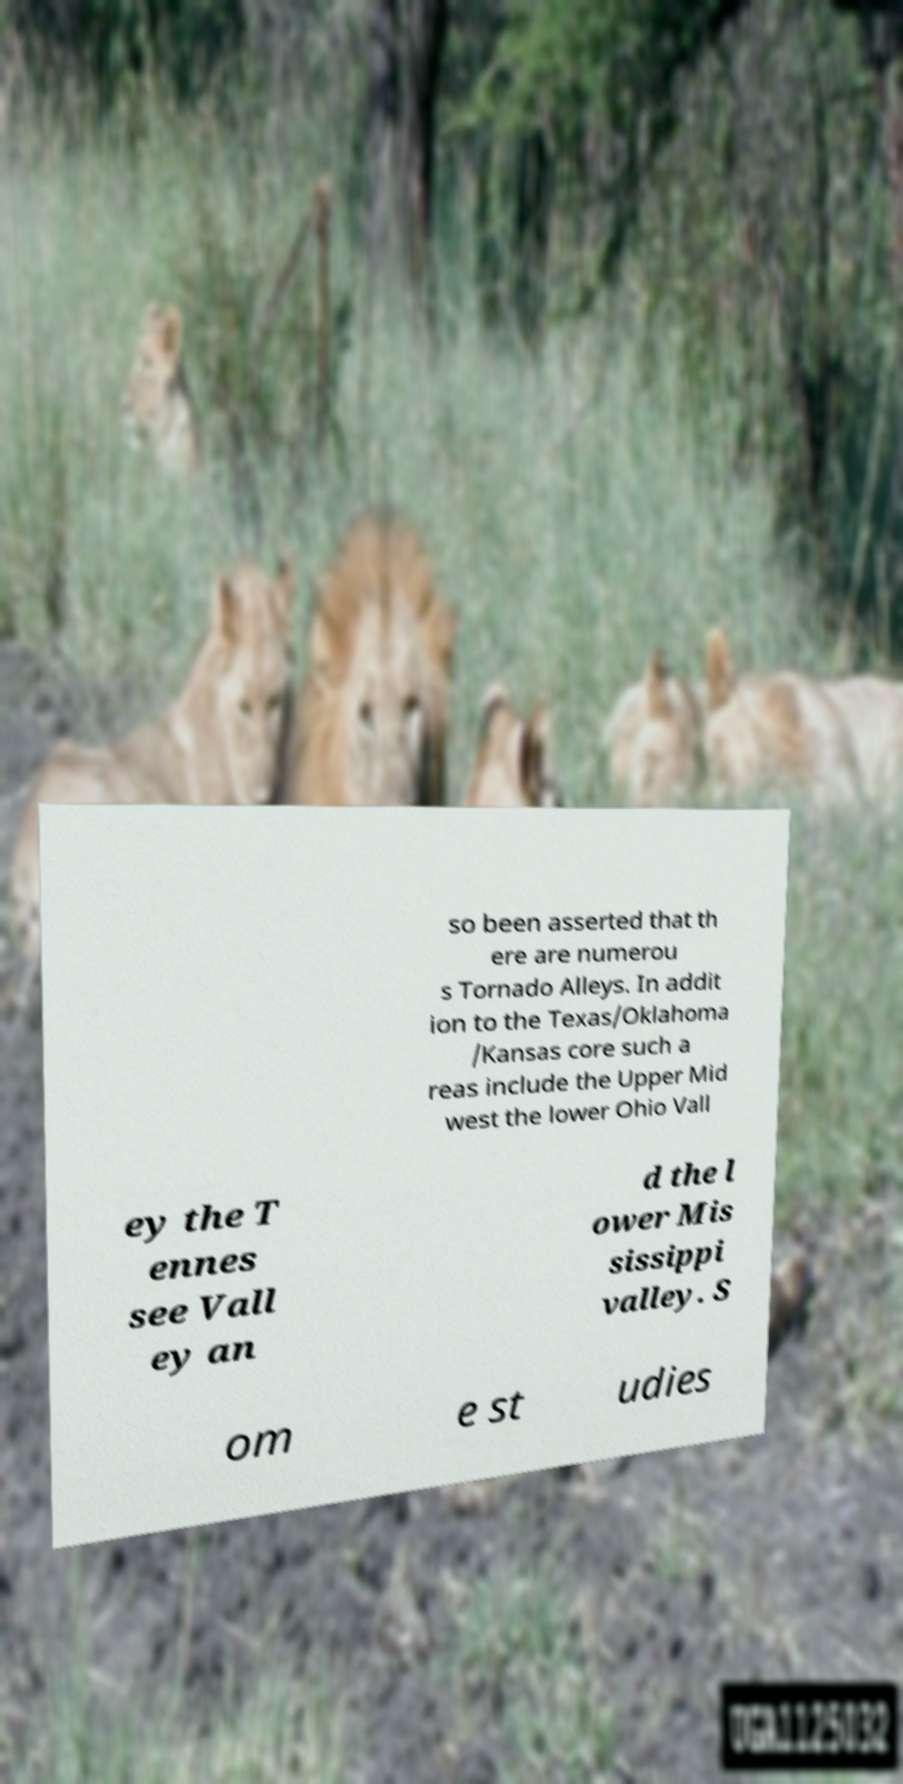Can you accurately transcribe the text from the provided image for me? so been asserted that th ere are numerou s Tornado Alleys. In addit ion to the Texas/Oklahoma /Kansas core such a reas include the Upper Mid west the lower Ohio Vall ey the T ennes see Vall ey an d the l ower Mis sissippi valley. S om e st udies 